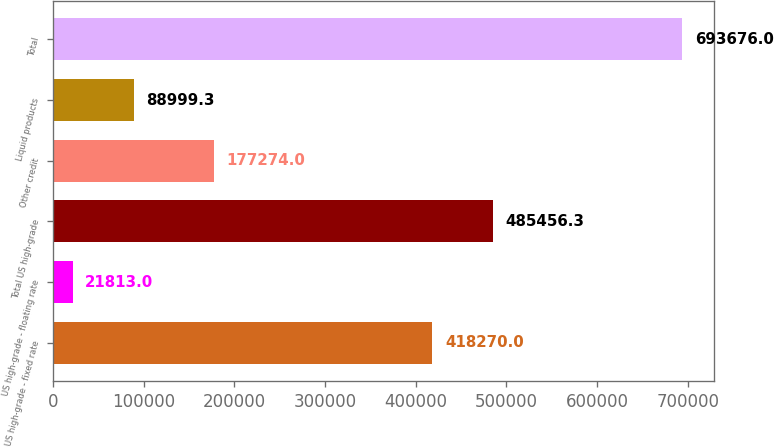<chart> <loc_0><loc_0><loc_500><loc_500><bar_chart><fcel>US high-grade - fixed rate<fcel>US high-grade - floating rate<fcel>Total US high-grade<fcel>Other credit<fcel>Liquid products<fcel>Total<nl><fcel>418270<fcel>21813<fcel>485456<fcel>177274<fcel>88999.3<fcel>693676<nl></chart> 